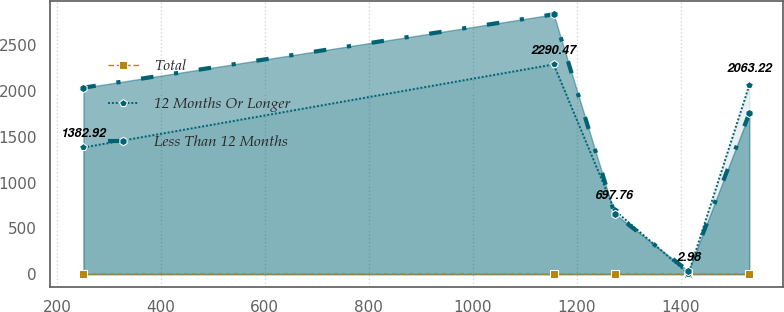<chart> <loc_0><loc_0><loc_500><loc_500><line_chart><ecel><fcel>Total<fcel>12 Months Or Longer<fcel>Less Than 12 Months<nl><fcel>251.13<fcel>0.57<fcel>1382.92<fcel>2035.87<nl><fcel>1155.97<fcel>0.47<fcel>2290.47<fcel>2837<nl><fcel>1273.1<fcel>0.77<fcel>697.76<fcel>659.68<nl><fcel>1415.23<fcel>0.67<fcel>2.98<fcel>32.32<nl><fcel>1532.36<fcel>1.48<fcel>2063.22<fcel>1755.4<nl></chart> 